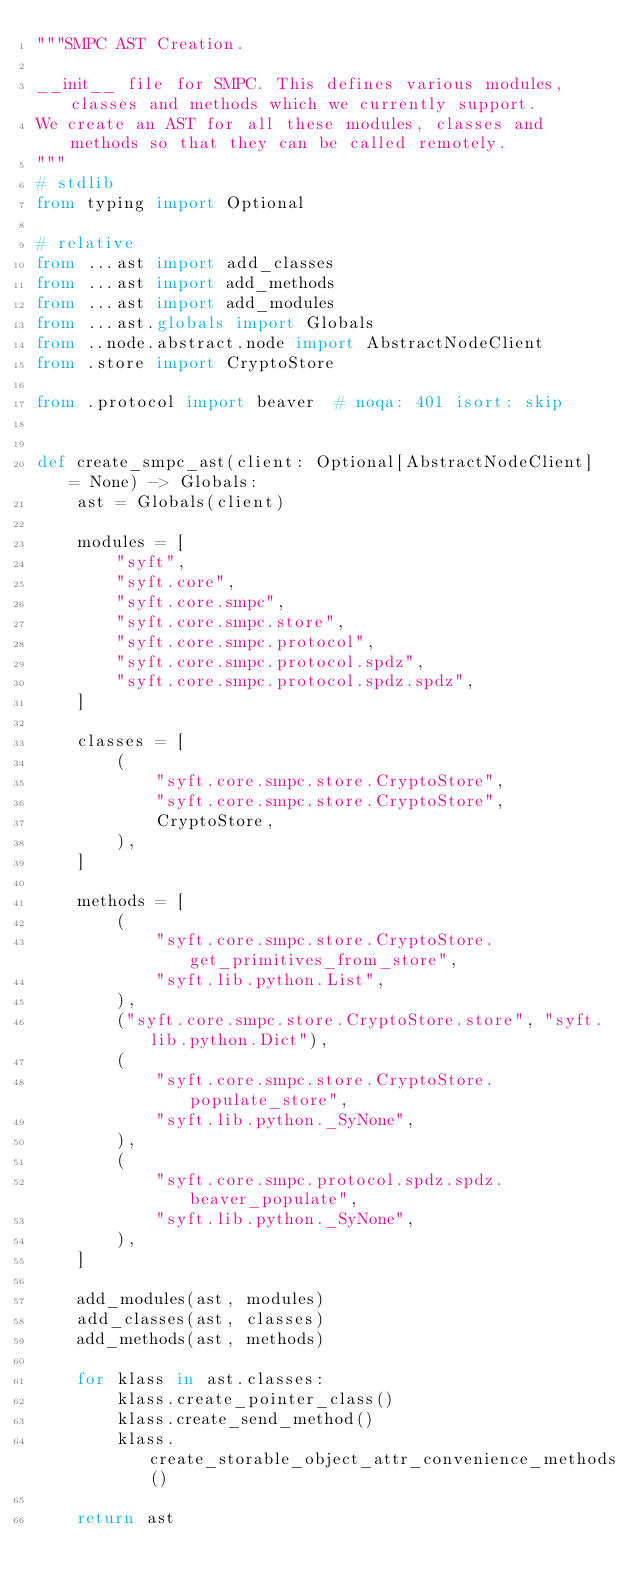<code> <loc_0><loc_0><loc_500><loc_500><_Python_>"""SMPC AST Creation.

__init__ file for SMPC. This defines various modules, classes and methods which we currently support.
We create an AST for all these modules, classes and methods so that they can be called remotely.
"""
# stdlib
from typing import Optional

# relative
from ...ast import add_classes
from ...ast import add_methods
from ...ast import add_modules
from ...ast.globals import Globals
from ..node.abstract.node import AbstractNodeClient
from .store import CryptoStore

from .protocol import beaver  # noqa: 401 isort: skip


def create_smpc_ast(client: Optional[AbstractNodeClient] = None) -> Globals:
    ast = Globals(client)

    modules = [
        "syft",
        "syft.core",
        "syft.core.smpc",
        "syft.core.smpc.store",
        "syft.core.smpc.protocol",
        "syft.core.smpc.protocol.spdz",
        "syft.core.smpc.protocol.spdz.spdz",
    ]

    classes = [
        (
            "syft.core.smpc.store.CryptoStore",
            "syft.core.smpc.store.CryptoStore",
            CryptoStore,
        ),
    ]

    methods = [
        (
            "syft.core.smpc.store.CryptoStore.get_primitives_from_store",
            "syft.lib.python.List",
        ),
        ("syft.core.smpc.store.CryptoStore.store", "syft.lib.python.Dict"),
        (
            "syft.core.smpc.store.CryptoStore.populate_store",
            "syft.lib.python._SyNone",
        ),
        (
            "syft.core.smpc.protocol.spdz.spdz.beaver_populate",
            "syft.lib.python._SyNone",
        ),
    ]

    add_modules(ast, modules)
    add_classes(ast, classes)
    add_methods(ast, methods)

    for klass in ast.classes:
        klass.create_pointer_class()
        klass.create_send_method()
        klass.create_storable_object_attr_convenience_methods()

    return ast
</code> 